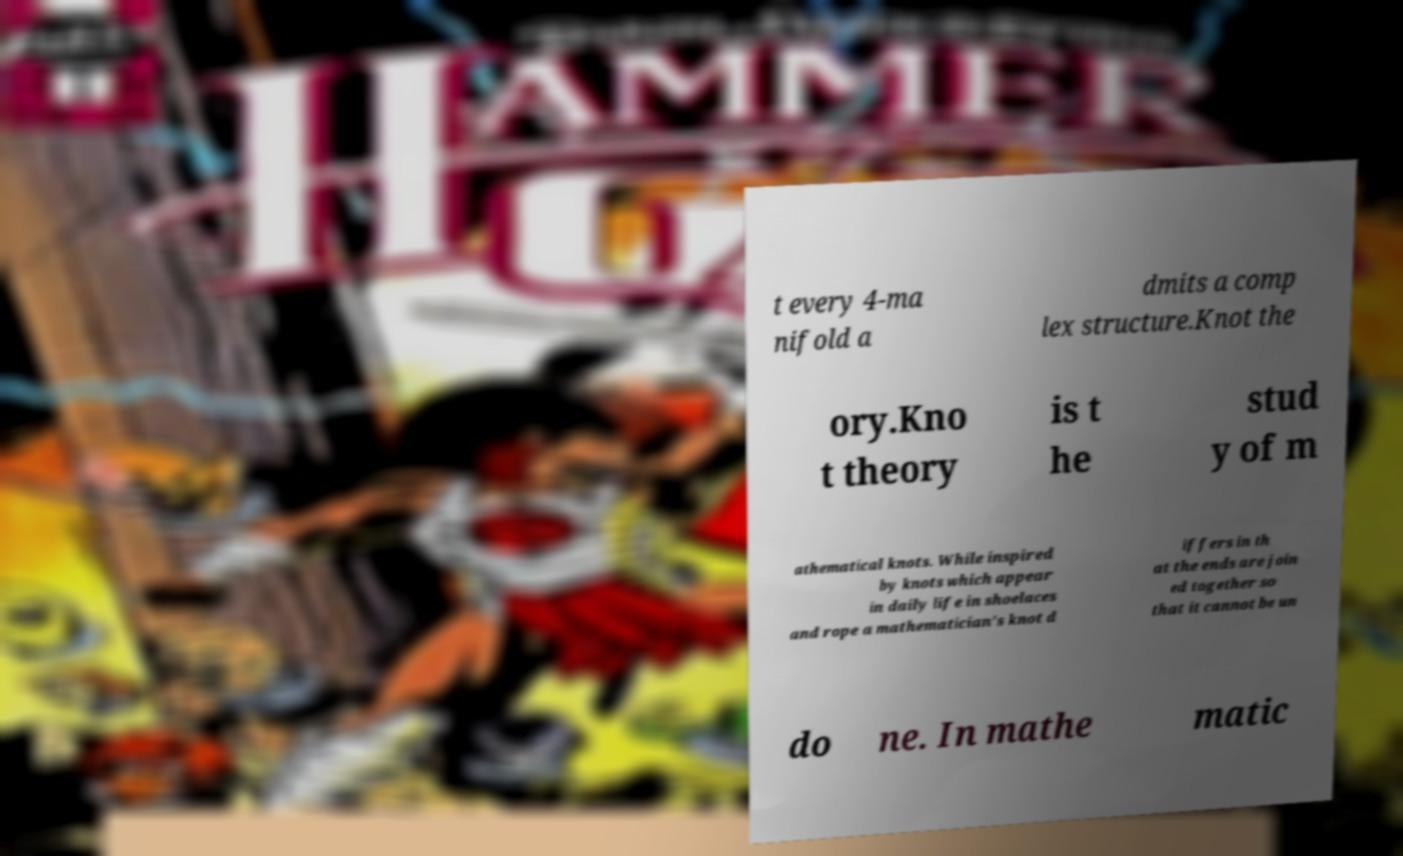What messages or text are displayed in this image? I need them in a readable, typed format. t every 4-ma nifold a dmits a comp lex structure.Knot the ory.Kno t theory is t he stud y of m athematical knots. While inspired by knots which appear in daily life in shoelaces and rope a mathematician's knot d iffers in th at the ends are join ed together so that it cannot be un do ne. In mathe matic 